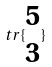Convert formula to latex. <formula><loc_0><loc_0><loc_500><loc_500>t r \{ \begin{matrix} 5 \\ 3 \end{matrix} \}</formula> 